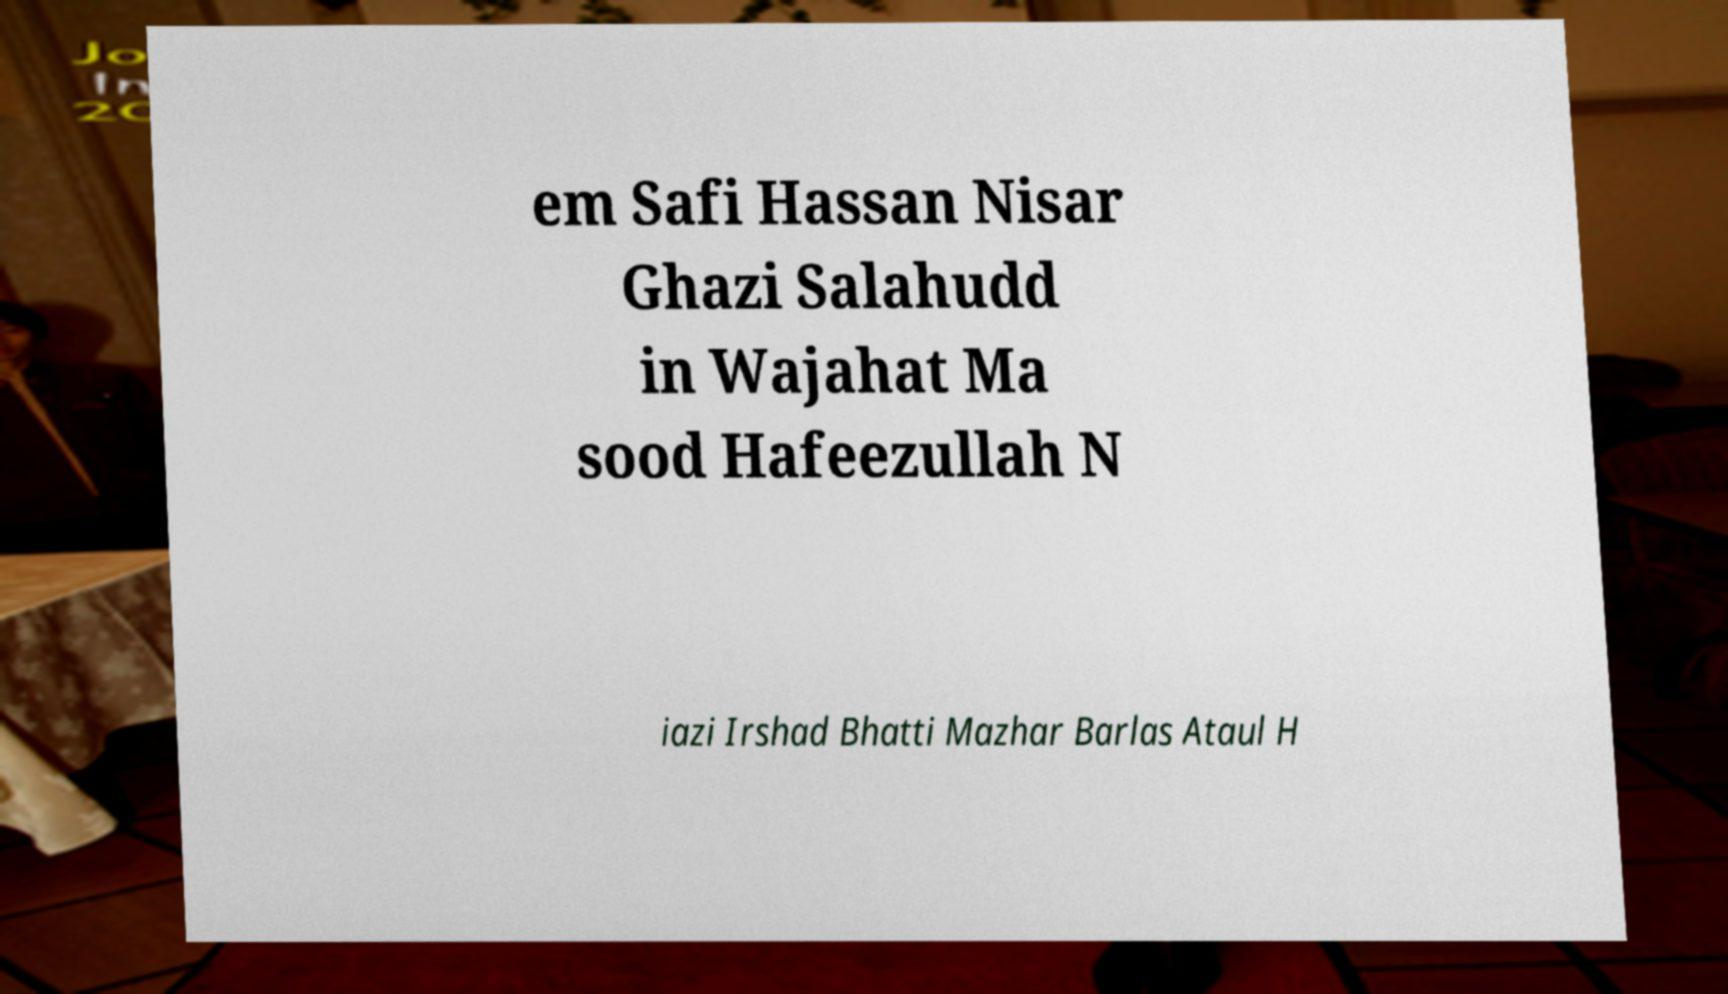Can you accurately transcribe the text from the provided image for me? em Safi Hassan Nisar Ghazi Salahudd in Wajahat Ma sood Hafeezullah N iazi Irshad Bhatti Mazhar Barlas Ataul H 